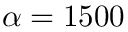Convert formula to latex. <formula><loc_0><loc_0><loc_500><loc_500>\alpha = 1 5 0 0</formula> 